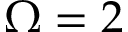<formula> <loc_0><loc_0><loc_500><loc_500>\Omega = 2</formula> 